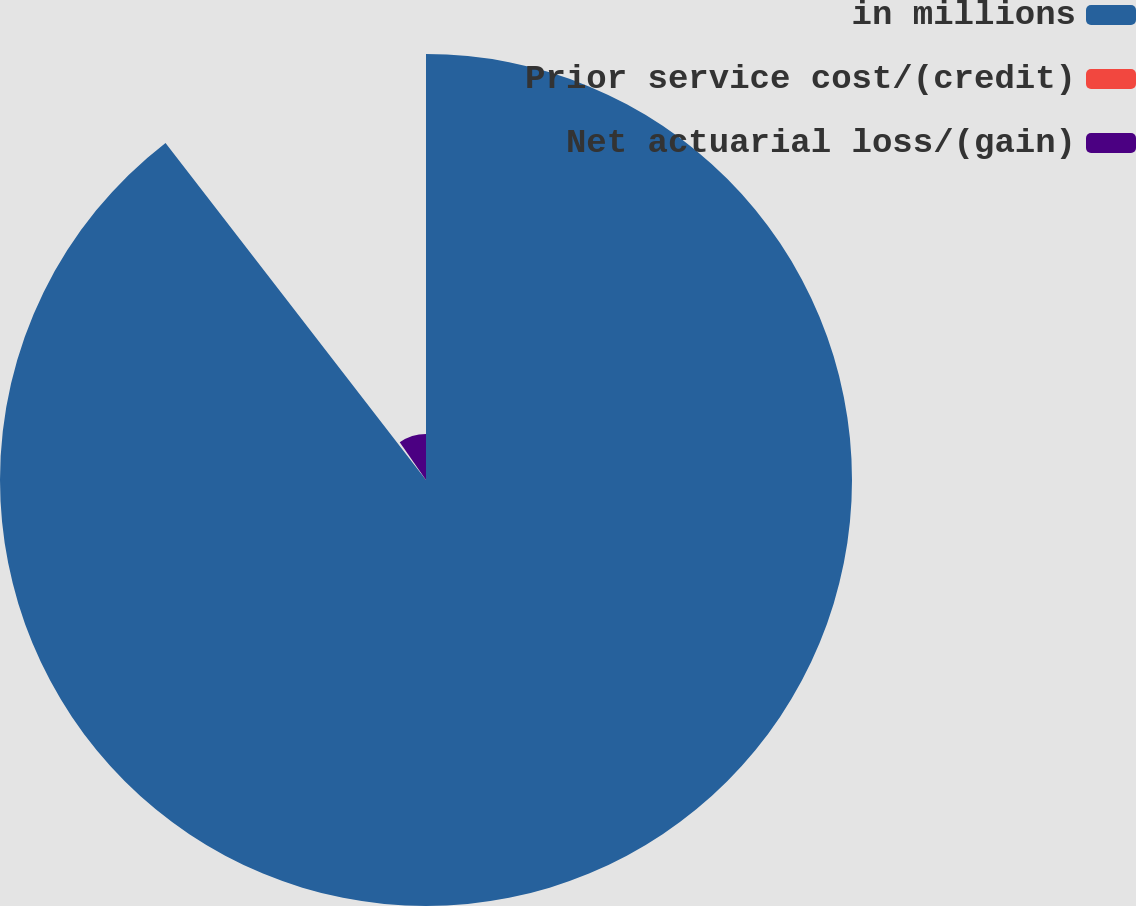Convert chart. <chart><loc_0><loc_0><loc_500><loc_500><pie_chart><fcel>in millions<fcel>Prior service cost/(credit)<fcel>Net actuarial loss/(gain)<nl><fcel>89.52%<fcel>0.8%<fcel>9.67%<nl></chart> 